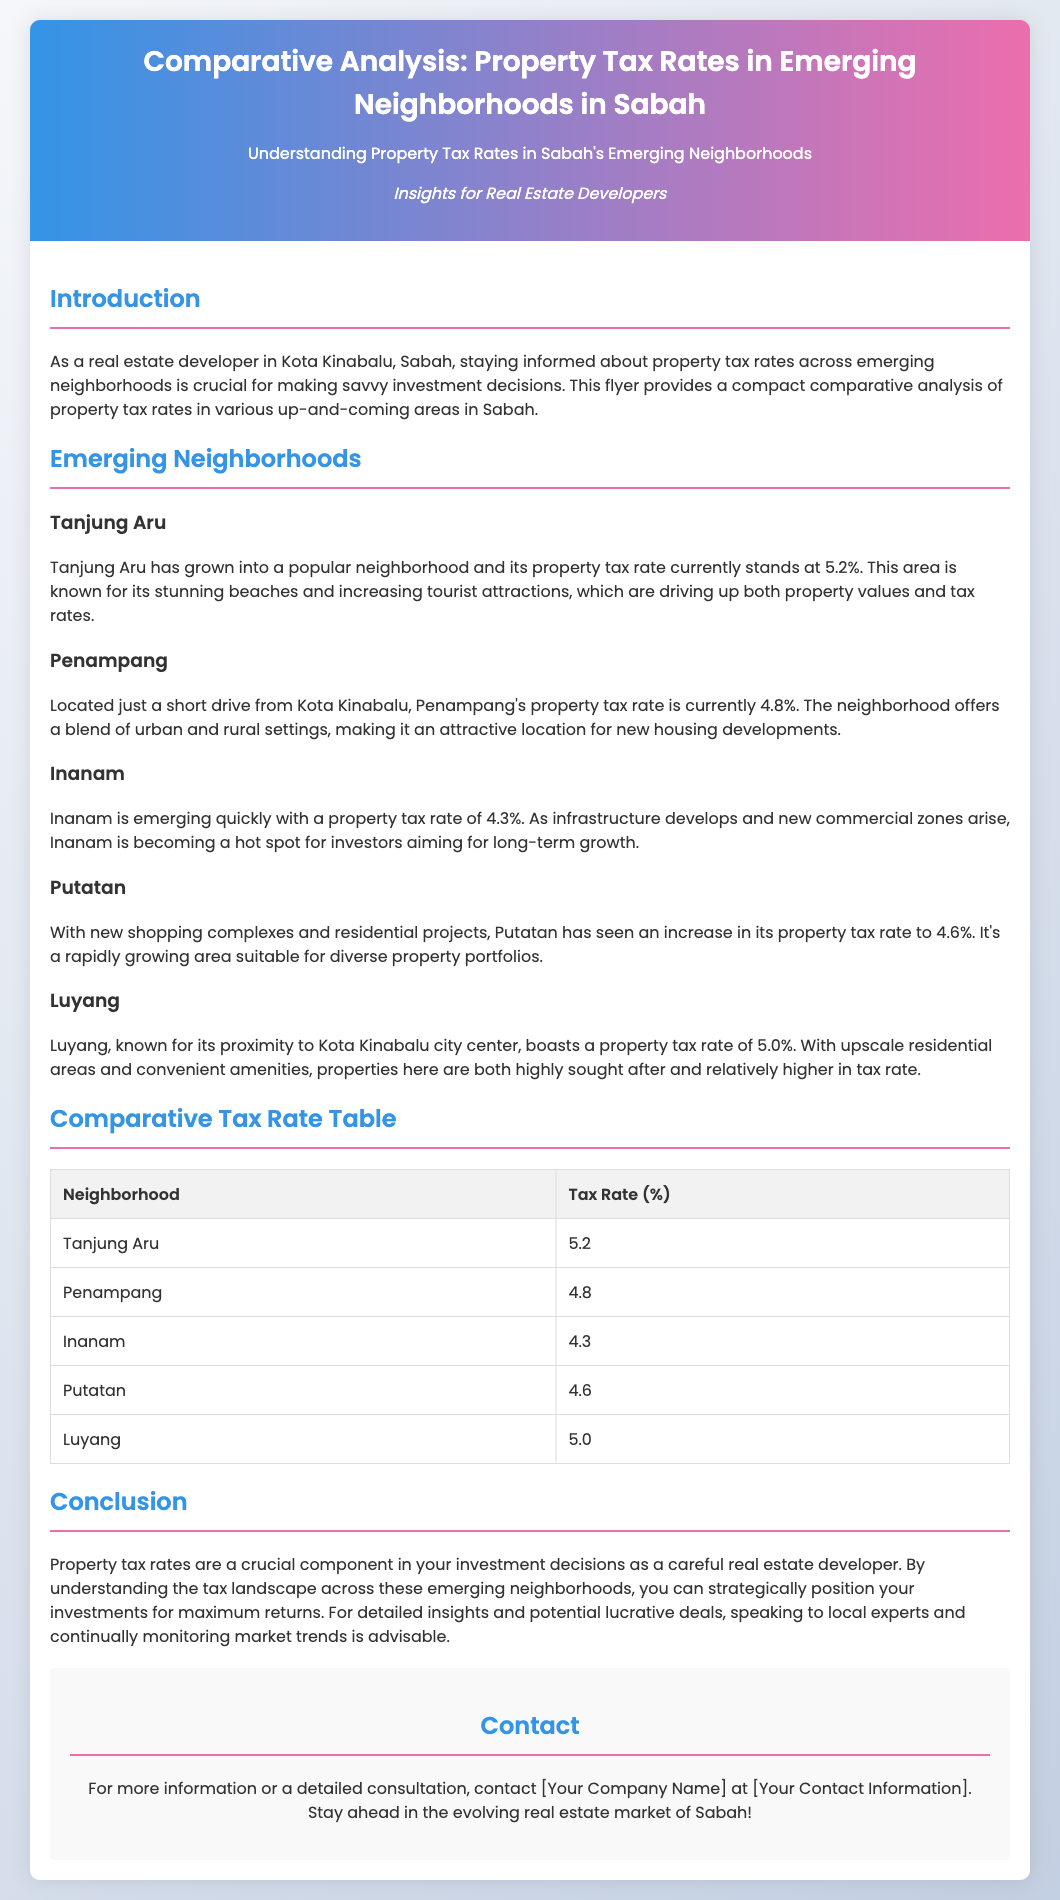What is the property tax rate for Tanjung Aru? The property tax rate for Tanjung Aru is stated clearly in the document as 5.2%.
Answer: 5.2% What is the property tax rate for Inanam? The document specifies that Inanam has a property tax rate of 4.3%.
Answer: 4.3% Which neighborhood has the highest property tax rate? The analysis presents that Tanjung Aru has the highest property tax rate at 5.2%, indicating its popularity.
Answer: Tanjung Aru What is the property tax rate for Penampang? The flyer lists Penampang's property tax rate as 4.8%.
Answer: 4.8% How does Luyang's property tax rate compare to Putatan? By comparing the rates in the document, Luyang's tax rate is 5.0%, while Putatan's is 4.6%, showing Luyang has a higher rate.
Answer: Luyang has a higher rate What key factor is driving up property values in Tanjung Aru? The document indicates that stunning beaches and increasing tourist attractions are driving up property values in Tanjung Aru.
Answer: Stunning beaches and increasing tourist attractions What type of document is this? This document is identified as a flyer aimed at real estate developers to provide insights into property tax rates.
Answer: A flyer What is emphasized for savvy investment decisions according to the flyer? The document emphasizes the importance of understanding property tax rates across neighborhoods for making savvy investment decisions.
Answer: Understanding property tax rates What information can be found in the comparative tax rate table? The table includes the neighborhoods listed alongside their respective property tax rates, summarizing the key data succinctly.
Answer: Neighborhoods and their property tax rates 